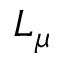<formula> <loc_0><loc_0><loc_500><loc_500>L _ { \mu }</formula> 